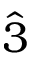<formula> <loc_0><loc_0><loc_500><loc_500>\hat { 3 }</formula> 